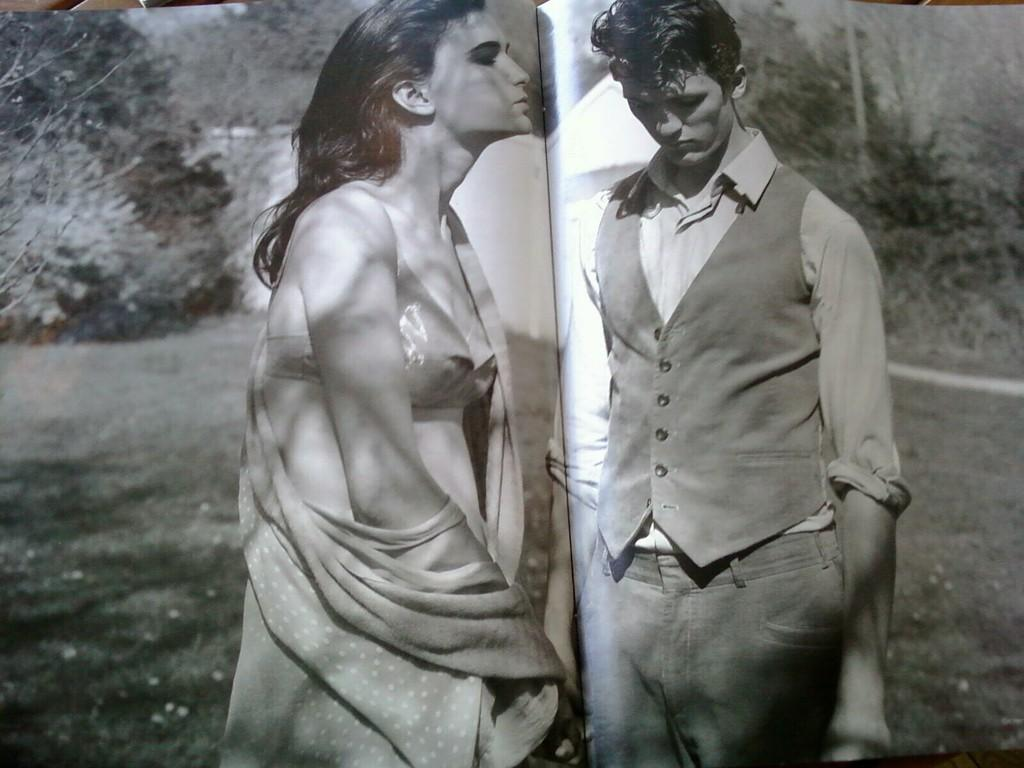What object can be seen in the image? There is a book in the image. Who is present in the image? There is a man and a woman standing in the image. What can be seen in the background of the image? There are trees in the background of the image. What is the color scheme of the image? The image is black and white. What type of donkey can be seen in the image? There is no donkey present in the image. How many friends are standing together in the image? The image does not specify whether the man and woman are friends or not, so we cannot determine the number of friends in the image. 